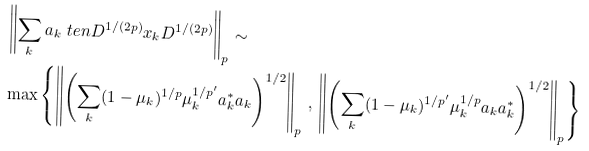<formula> <loc_0><loc_0><loc_500><loc_500>& \left \| \sum _ { k } a _ { k } \ t e n D ^ { 1 / ( 2 p ) } x _ { k } D ^ { 1 / ( 2 p ) } \right \| _ { p } \sim \\ & \max \left \{ \left \| \left ( \sum _ { k } ( 1 - \mu _ { k } ) ^ { 1 / p } \mu _ { k } ^ { 1 / p ^ { \prime } } a _ { k } ^ { * } a _ { k } \right ) ^ { 1 / 2 } \right \| _ { p } \, , \, \left \| \left ( \sum _ { k } ( 1 - \mu _ { k } ) ^ { 1 / p ^ { \prime } } \mu _ { k } ^ { 1 / p } a _ { k } a _ { k } ^ { * } \right ) ^ { 1 / 2 } \right \| _ { p } \right \}</formula> 